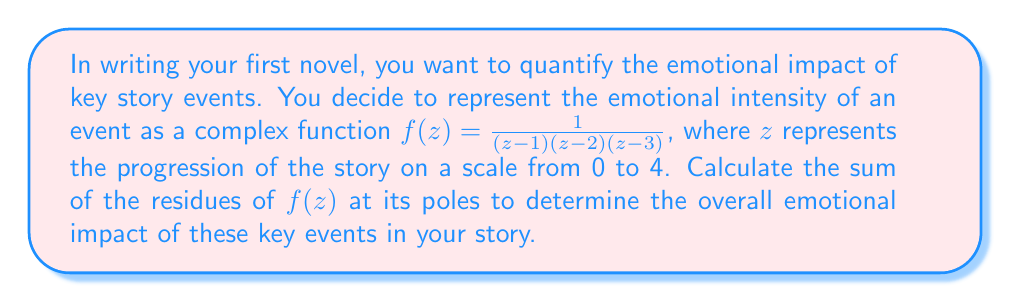Can you solve this math problem? To solve this problem, we need to follow these steps:

1) Identify the poles of the function:
   The poles are at $z = 1$, $z = 2$, and $z = 3$.

2) Calculate the residue at each pole:
   For a simple pole at $z = a$, the residue is given by:
   $$\text{Res}(f, a) = \lim_{z \to a} (z-a)f(z)$$

   a) For $z = 1$:
      $$\begin{align}
      \text{Res}(f, 1) &= \lim_{z \to 1} (z-1)\frac{1}{(z-1)(z-2)(z-3)} \\
      &= \lim_{z \to 1} \frac{1}{(z-2)(z-3)} \\
      &= \frac{1}{(1-2)(1-3)} = \frac{1}{2}
      \end{align}$$

   b) For $z = 2$:
      $$\begin{align}
      \text{Res}(f, 2) &= \lim_{z \to 2} (z-2)\frac{1}{(z-1)(z-2)(z-3)} \\
      &= \lim_{z \to 2} \frac{1}{(z-1)(z-3)} \\
      &= \frac{1}{(2-1)(2-3)} = -1
      \end{align}$$

   c) For $z = 3$:
      $$\begin{align}
      \text{Res}(f, 3) &= \lim_{z \to 3} (z-3)\frac{1}{(z-1)(z-2)(z-3)} \\
      &= \lim_{z \to 3} \frac{1}{(z-1)(z-2)} \\
      &= \frac{1}{(3-1)(3-2)} = \frac{1}{2}
      \end{align}$$

3) Sum the residues:
   $$\text{Sum of residues} = \frac{1}{2} + (-1) + \frac{1}{2} = 0$$

The sum of the residues represents the overall emotional impact of the key events in your story. In this case, the sum being zero suggests a balance of emotional highs and lows throughout the narrative.
Answer: The sum of the residues is 0, indicating a balanced emotional impact of key events in the story. 